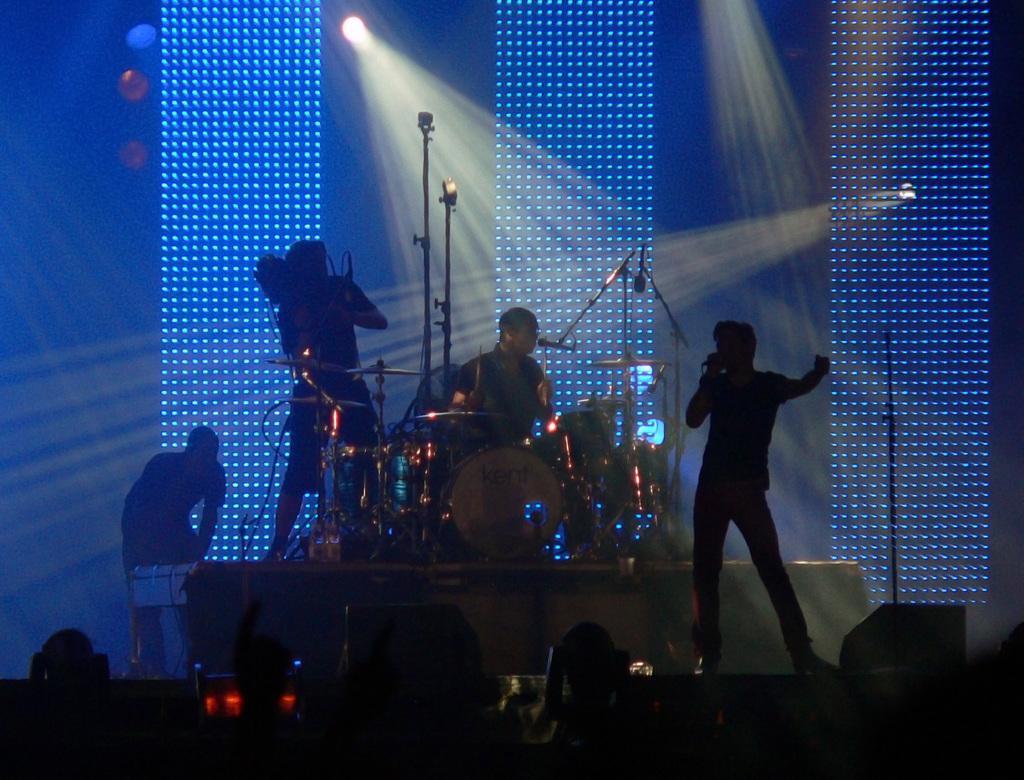Could you give a brief overview of what you see in this image? A man is standing and singing a song in the middle a man is beating the drums there are lights at the back. 